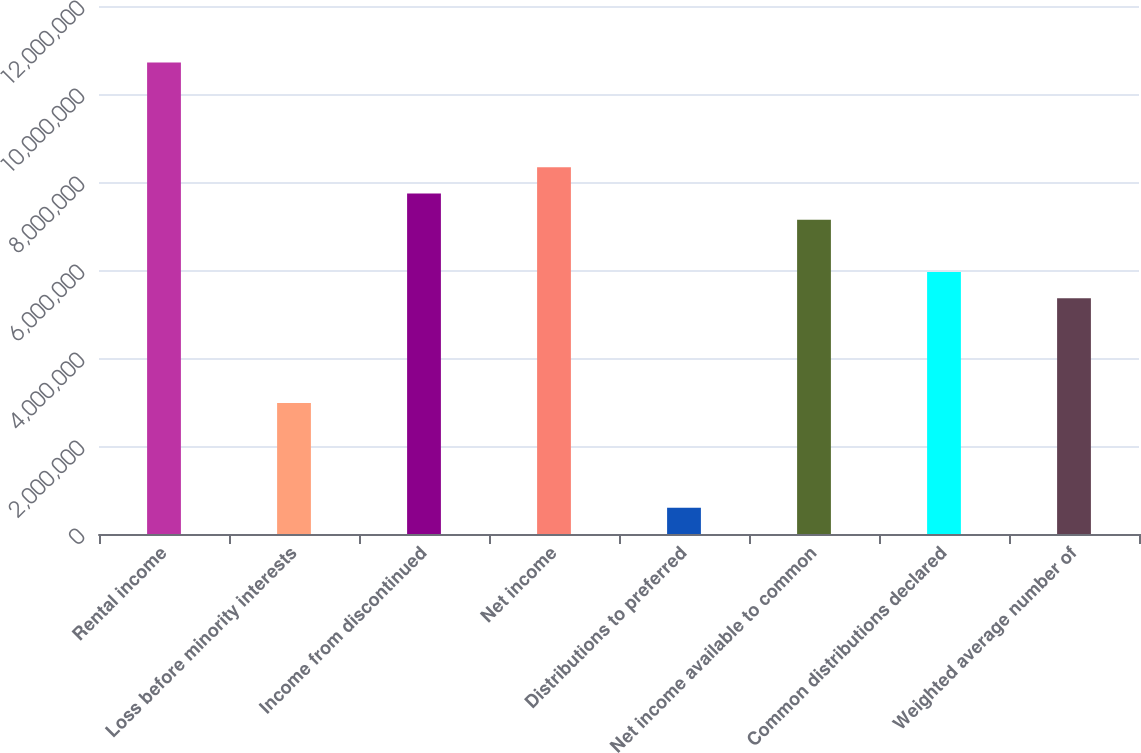Convert chart. <chart><loc_0><loc_0><loc_500><loc_500><bar_chart><fcel>Rental income<fcel>Loss before minority interests<fcel>Income from discontinued<fcel>Net income<fcel>Distributions to preferred<fcel>Net income available to common<fcel>Common distributions declared<fcel>Weighted average number of<nl><fcel>1.07146e+07<fcel>2.97627e+06<fcel>7.7383e+06<fcel>8.33356e+06<fcel>595254<fcel>7.14305e+06<fcel>5.95254e+06<fcel>5.35729e+06<nl></chart> 